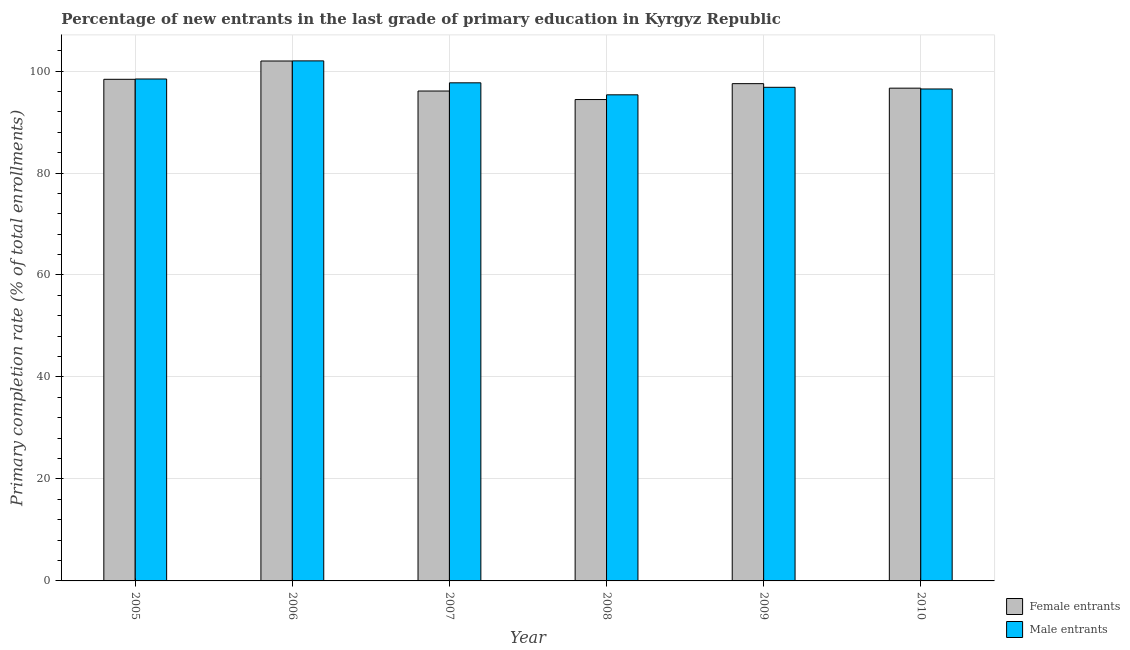How many different coloured bars are there?
Your answer should be compact. 2. Are the number of bars on each tick of the X-axis equal?
Ensure brevity in your answer.  Yes. How many bars are there on the 1st tick from the left?
Keep it short and to the point. 2. What is the label of the 5th group of bars from the left?
Offer a very short reply. 2009. In how many cases, is the number of bars for a given year not equal to the number of legend labels?
Your response must be concise. 0. What is the primary completion rate of male entrants in 2010?
Offer a very short reply. 96.48. Across all years, what is the maximum primary completion rate of male entrants?
Your answer should be very brief. 101.99. Across all years, what is the minimum primary completion rate of male entrants?
Your answer should be very brief. 95.33. In which year was the primary completion rate of female entrants maximum?
Ensure brevity in your answer.  2006. In which year was the primary completion rate of female entrants minimum?
Your answer should be very brief. 2008. What is the total primary completion rate of female entrants in the graph?
Ensure brevity in your answer.  584.98. What is the difference between the primary completion rate of female entrants in 2007 and that in 2010?
Provide a short and direct response. -0.56. What is the difference between the primary completion rate of male entrants in 2008 and the primary completion rate of female entrants in 2006?
Offer a terse response. -6.66. What is the average primary completion rate of male entrants per year?
Provide a succinct answer. 97.79. What is the ratio of the primary completion rate of female entrants in 2009 to that in 2010?
Offer a terse response. 1.01. Is the primary completion rate of male entrants in 2005 less than that in 2007?
Keep it short and to the point. No. What is the difference between the highest and the second highest primary completion rate of male entrants?
Give a very brief answer. 3.55. What is the difference between the highest and the lowest primary completion rate of female entrants?
Your answer should be compact. 7.56. In how many years, is the primary completion rate of female entrants greater than the average primary completion rate of female entrants taken over all years?
Your answer should be compact. 3. What does the 2nd bar from the left in 2005 represents?
Offer a terse response. Male entrants. What does the 1st bar from the right in 2007 represents?
Keep it short and to the point. Male entrants. Are the values on the major ticks of Y-axis written in scientific E-notation?
Your answer should be compact. No. What is the title of the graph?
Offer a terse response. Percentage of new entrants in the last grade of primary education in Kyrgyz Republic. What is the label or title of the X-axis?
Make the answer very short. Year. What is the label or title of the Y-axis?
Your answer should be compact. Primary completion rate (% of total enrollments). What is the Primary completion rate (% of total enrollments) of Female entrants in 2005?
Give a very brief answer. 98.38. What is the Primary completion rate (% of total enrollments) in Male entrants in 2005?
Ensure brevity in your answer.  98.44. What is the Primary completion rate (% of total enrollments) of Female entrants in 2006?
Make the answer very short. 101.97. What is the Primary completion rate (% of total enrollments) in Male entrants in 2006?
Provide a short and direct response. 101.99. What is the Primary completion rate (% of total enrollments) of Female entrants in 2007?
Give a very brief answer. 96.08. What is the Primary completion rate (% of total enrollments) in Male entrants in 2007?
Your response must be concise. 97.69. What is the Primary completion rate (% of total enrollments) of Female entrants in 2008?
Your answer should be very brief. 94.41. What is the Primary completion rate (% of total enrollments) in Male entrants in 2008?
Provide a short and direct response. 95.33. What is the Primary completion rate (% of total enrollments) in Female entrants in 2009?
Your response must be concise. 97.52. What is the Primary completion rate (% of total enrollments) of Male entrants in 2009?
Give a very brief answer. 96.81. What is the Primary completion rate (% of total enrollments) of Female entrants in 2010?
Your answer should be compact. 96.64. What is the Primary completion rate (% of total enrollments) in Male entrants in 2010?
Provide a succinct answer. 96.48. Across all years, what is the maximum Primary completion rate (% of total enrollments) in Female entrants?
Your answer should be compact. 101.97. Across all years, what is the maximum Primary completion rate (% of total enrollments) in Male entrants?
Your response must be concise. 101.99. Across all years, what is the minimum Primary completion rate (% of total enrollments) in Female entrants?
Provide a succinct answer. 94.41. Across all years, what is the minimum Primary completion rate (% of total enrollments) of Male entrants?
Offer a very short reply. 95.33. What is the total Primary completion rate (% of total enrollments) in Female entrants in the graph?
Your answer should be compact. 584.98. What is the total Primary completion rate (% of total enrollments) in Male entrants in the graph?
Provide a short and direct response. 586.73. What is the difference between the Primary completion rate (% of total enrollments) in Female entrants in 2005 and that in 2006?
Ensure brevity in your answer.  -3.59. What is the difference between the Primary completion rate (% of total enrollments) of Male entrants in 2005 and that in 2006?
Provide a short and direct response. -3.55. What is the difference between the Primary completion rate (% of total enrollments) of Female entrants in 2005 and that in 2007?
Your answer should be very brief. 2.3. What is the difference between the Primary completion rate (% of total enrollments) of Male entrants in 2005 and that in 2007?
Provide a succinct answer. 0.75. What is the difference between the Primary completion rate (% of total enrollments) in Female entrants in 2005 and that in 2008?
Offer a terse response. 3.97. What is the difference between the Primary completion rate (% of total enrollments) in Male entrants in 2005 and that in 2008?
Make the answer very short. 3.11. What is the difference between the Primary completion rate (% of total enrollments) in Female entrants in 2005 and that in 2009?
Offer a very short reply. 0.85. What is the difference between the Primary completion rate (% of total enrollments) in Male entrants in 2005 and that in 2009?
Keep it short and to the point. 1.63. What is the difference between the Primary completion rate (% of total enrollments) in Female entrants in 2005 and that in 2010?
Offer a terse response. 1.74. What is the difference between the Primary completion rate (% of total enrollments) in Male entrants in 2005 and that in 2010?
Offer a very short reply. 1.96. What is the difference between the Primary completion rate (% of total enrollments) in Female entrants in 2006 and that in 2007?
Give a very brief answer. 5.89. What is the difference between the Primary completion rate (% of total enrollments) of Male entrants in 2006 and that in 2007?
Your response must be concise. 4.3. What is the difference between the Primary completion rate (% of total enrollments) of Female entrants in 2006 and that in 2008?
Give a very brief answer. 7.56. What is the difference between the Primary completion rate (% of total enrollments) in Male entrants in 2006 and that in 2008?
Keep it short and to the point. 6.66. What is the difference between the Primary completion rate (% of total enrollments) of Female entrants in 2006 and that in 2009?
Give a very brief answer. 4.44. What is the difference between the Primary completion rate (% of total enrollments) in Male entrants in 2006 and that in 2009?
Offer a terse response. 5.18. What is the difference between the Primary completion rate (% of total enrollments) in Female entrants in 2006 and that in 2010?
Your response must be concise. 5.33. What is the difference between the Primary completion rate (% of total enrollments) in Male entrants in 2006 and that in 2010?
Your response must be concise. 5.51. What is the difference between the Primary completion rate (% of total enrollments) of Female entrants in 2007 and that in 2008?
Your answer should be compact. 1.67. What is the difference between the Primary completion rate (% of total enrollments) of Male entrants in 2007 and that in 2008?
Offer a very short reply. 2.35. What is the difference between the Primary completion rate (% of total enrollments) in Female entrants in 2007 and that in 2009?
Keep it short and to the point. -1.45. What is the difference between the Primary completion rate (% of total enrollments) of Male entrants in 2007 and that in 2009?
Keep it short and to the point. 0.88. What is the difference between the Primary completion rate (% of total enrollments) in Female entrants in 2007 and that in 2010?
Provide a succinct answer. -0.56. What is the difference between the Primary completion rate (% of total enrollments) of Male entrants in 2007 and that in 2010?
Ensure brevity in your answer.  1.21. What is the difference between the Primary completion rate (% of total enrollments) of Female entrants in 2008 and that in 2009?
Make the answer very short. -3.12. What is the difference between the Primary completion rate (% of total enrollments) of Male entrants in 2008 and that in 2009?
Provide a succinct answer. -1.48. What is the difference between the Primary completion rate (% of total enrollments) in Female entrants in 2008 and that in 2010?
Your answer should be very brief. -2.23. What is the difference between the Primary completion rate (% of total enrollments) of Male entrants in 2008 and that in 2010?
Offer a very short reply. -1.15. What is the difference between the Primary completion rate (% of total enrollments) of Female entrants in 2009 and that in 2010?
Make the answer very short. 0.89. What is the difference between the Primary completion rate (% of total enrollments) of Male entrants in 2009 and that in 2010?
Your answer should be very brief. 0.33. What is the difference between the Primary completion rate (% of total enrollments) in Female entrants in 2005 and the Primary completion rate (% of total enrollments) in Male entrants in 2006?
Give a very brief answer. -3.61. What is the difference between the Primary completion rate (% of total enrollments) in Female entrants in 2005 and the Primary completion rate (% of total enrollments) in Male entrants in 2007?
Your answer should be compact. 0.69. What is the difference between the Primary completion rate (% of total enrollments) of Female entrants in 2005 and the Primary completion rate (% of total enrollments) of Male entrants in 2008?
Offer a very short reply. 3.04. What is the difference between the Primary completion rate (% of total enrollments) in Female entrants in 2005 and the Primary completion rate (% of total enrollments) in Male entrants in 2009?
Ensure brevity in your answer.  1.57. What is the difference between the Primary completion rate (% of total enrollments) in Female entrants in 2005 and the Primary completion rate (% of total enrollments) in Male entrants in 2010?
Ensure brevity in your answer.  1.9. What is the difference between the Primary completion rate (% of total enrollments) in Female entrants in 2006 and the Primary completion rate (% of total enrollments) in Male entrants in 2007?
Make the answer very short. 4.28. What is the difference between the Primary completion rate (% of total enrollments) of Female entrants in 2006 and the Primary completion rate (% of total enrollments) of Male entrants in 2008?
Provide a short and direct response. 6.63. What is the difference between the Primary completion rate (% of total enrollments) in Female entrants in 2006 and the Primary completion rate (% of total enrollments) in Male entrants in 2009?
Offer a terse response. 5.16. What is the difference between the Primary completion rate (% of total enrollments) in Female entrants in 2006 and the Primary completion rate (% of total enrollments) in Male entrants in 2010?
Provide a succinct answer. 5.49. What is the difference between the Primary completion rate (% of total enrollments) in Female entrants in 2007 and the Primary completion rate (% of total enrollments) in Male entrants in 2008?
Your answer should be very brief. 0.74. What is the difference between the Primary completion rate (% of total enrollments) of Female entrants in 2007 and the Primary completion rate (% of total enrollments) of Male entrants in 2009?
Offer a terse response. -0.73. What is the difference between the Primary completion rate (% of total enrollments) in Female entrants in 2007 and the Primary completion rate (% of total enrollments) in Male entrants in 2010?
Your response must be concise. -0.4. What is the difference between the Primary completion rate (% of total enrollments) of Female entrants in 2008 and the Primary completion rate (% of total enrollments) of Male entrants in 2009?
Provide a succinct answer. -2.4. What is the difference between the Primary completion rate (% of total enrollments) in Female entrants in 2008 and the Primary completion rate (% of total enrollments) in Male entrants in 2010?
Offer a very short reply. -2.07. What is the difference between the Primary completion rate (% of total enrollments) in Female entrants in 2009 and the Primary completion rate (% of total enrollments) in Male entrants in 2010?
Offer a terse response. 1.04. What is the average Primary completion rate (% of total enrollments) in Female entrants per year?
Make the answer very short. 97.5. What is the average Primary completion rate (% of total enrollments) of Male entrants per year?
Your answer should be compact. 97.79. In the year 2005, what is the difference between the Primary completion rate (% of total enrollments) of Female entrants and Primary completion rate (% of total enrollments) of Male entrants?
Keep it short and to the point. -0.06. In the year 2006, what is the difference between the Primary completion rate (% of total enrollments) of Female entrants and Primary completion rate (% of total enrollments) of Male entrants?
Your answer should be very brief. -0.02. In the year 2007, what is the difference between the Primary completion rate (% of total enrollments) of Female entrants and Primary completion rate (% of total enrollments) of Male entrants?
Offer a terse response. -1.61. In the year 2008, what is the difference between the Primary completion rate (% of total enrollments) in Female entrants and Primary completion rate (% of total enrollments) in Male entrants?
Offer a terse response. -0.93. In the year 2009, what is the difference between the Primary completion rate (% of total enrollments) in Female entrants and Primary completion rate (% of total enrollments) in Male entrants?
Offer a very short reply. 0.71. In the year 2010, what is the difference between the Primary completion rate (% of total enrollments) of Female entrants and Primary completion rate (% of total enrollments) of Male entrants?
Your response must be concise. 0.16. What is the ratio of the Primary completion rate (% of total enrollments) in Female entrants in 2005 to that in 2006?
Ensure brevity in your answer.  0.96. What is the ratio of the Primary completion rate (% of total enrollments) of Male entrants in 2005 to that in 2006?
Offer a very short reply. 0.97. What is the ratio of the Primary completion rate (% of total enrollments) in Female entrants in 2005 to that in 2007?
Your response must be concise. 1.02. What is the ratio of the Primary completion rate (% of total enrollments) in Male entrants in 2005 to that in 2007?
Make the answer very short. 1.01. What is the ratio of the Primary completion rate (% of total enrollments) in Female entrants in 2005 to that in 2008?
Make the answer very short. 1.04. What is the ratio of the Primary completion rate (% of total enrollments) of Male entrants in 2005 to that in 2008?
Your answer should be compact. 1.03. What is the ratio of the Primary completion rate (% of total enrollments) in Female entrants in 2005 to that in 2009?
Provide a succinct answer. 1.01. What is the ratio of the Primary completion rate (% of total enrollments) in Male entrants in 2005 to that in 2009?
Your answer should be very brief. 1.02. What is the ratio of the Primary completion rate (% of total enrollments) of Male entrants in 2005 to that in 2010?
Offer a terse response. 1.02. What is the ratio of the Primary completion rate (% of total enrollments) in Female entrants in 2006 to that in 2007?
Offer a terse response. 1.06. What is the ratio of the Primary completion rate (% of total enrollments) in Male entrants in 2006 to that in 2007?
Keep it short and to the point. 1.04. What is the ratio of the Primary completion rate (% of total enrollments) of Female entrants in 2006 to that in 2008?
Ensure brevity in your answer.  1.08. What is the ratio of the Primary completion rate (% of total enrollments) of Male entrants in 2006 to that in 2008?
Give a very brief answer. 1.07. What is the ratio of the Primary completion rate (% of total enrollments) of Female entrants in 2006 to that in 2009?
Offer a very short reply. 1.05. What is the ratio of the Primary completion rate (% of total enrollments) in Male entrants in 2006 to that in 2009?
Provide a short and direct response. 1.05. What is the ratio of the Primary completion rate (% of total enrollments) of Female entrants in 2006 to that in 2010?
Provide a short and direct response. 1.06. What is the ratio of the Primary completion rate (% of total enrollments) of Male entrants in 2006 to that in 2010?
Ensure brevity in your answer.  1.06. What is the ratio of the Primary completion rate (% of total enrollments) in Female entrants in 2007 to that in 2008?
Your response must be concise. 1.02. What is the ratio of the Primary completion rate (% of total enrollments) of Male entrants in 2007 to that in 2008?
Provide a short and direct response. 1.02. What is the ratio of the Primary completion rate (% of total enrollments) of Female entrants in 2007 to that in 2009?
Provide a short and direct response. 0.99. What is the ratio of the Primary completion rate (% of total enrollments) of Male entrants in 2007 to that in 2009?
Your answer should be compact. 1.01. What is the ratio of the Primary completion rate (% of total enrollments) in Female entrants in 2007 to that in 2010?
Offer a very short reply. 0.99. What is the ratio of the Primary completion rate (% of total enrollments) of Male entrants in 2007 to that in 2010?
Offer a very short reply. 1.01. What is the ratio of the Primary completion rate (% of total enrollments) in Female entrants in 2008 to that in 2009?
Offer a very short reply. 0.97. What is the ratio of the Primary completion rate (% of total enrollments) of Male entrants in 2008 to that in 2009?
Provide a succinct answer. 0.98. What is the ratio of the Primary completion rate (% of total enrollments) in Female entrants in 2008 to that in 2010?
Provide a short and direct response. 0.98. What is the ratio of the Primary completion rate (% of total enrollments) in Male entrants in 2008 to that in 2010?
Your answer should be compact. 0.99. What is the ratio of the Primary completion rate (% of total enrollments) in Female entrants in 2009 to that in 2010?
Your answer should be compact. 1.01. What is the difference between the highest and the second highest Primary completion rate (% of total enrollments) of Female entrants?
Offer a very short reply. 3.59. What is the difference between the highest and the second highest Primary completion rate (% of total enrollments) of Male entrants?
Ensure brevity in your answer.  3.55. What is the difference between the highest and the lowest Primary completion rate (% of total enrollments) of Female entrants?
Provide a succinct answer. 7.56. What is the difference between the highest and the lowest Primary completion rate (% of total enrollments) in Male entrants?
Offer a terse response. 6.66. 